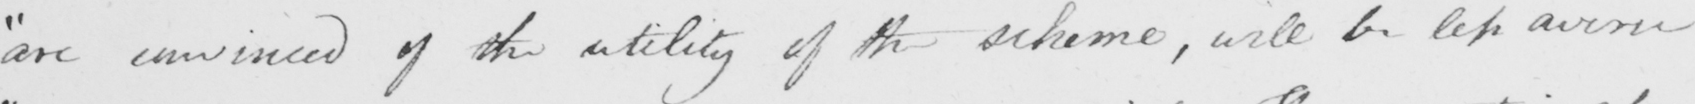Can you tell me what this handwritten text says? " are convinced of the utility of the scheme , will be less averse 